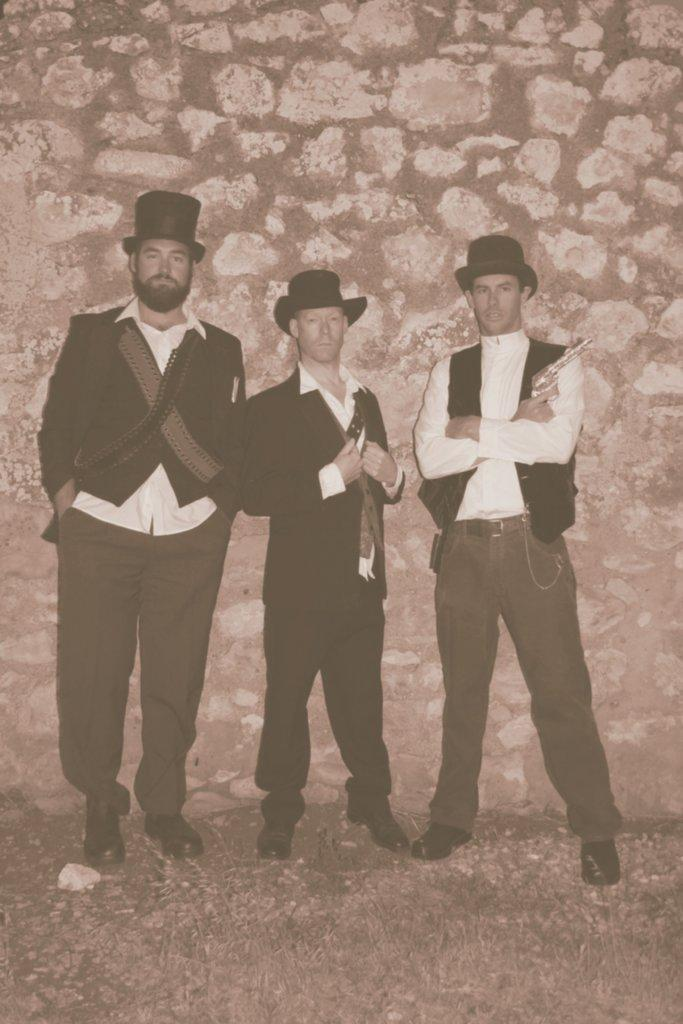How many people are in the image? There are three men in the image. What are the men doing in the image? The men are standing together in the image. What is behind the men in the image? They are in front of a wall. Can you describe any objects or items the men are holding? One of the men is holding a gun. What type of jam is being spread on the match in the image? There is no match or jam present in the image. Where is the park located in the image? There is no park present in the image. 